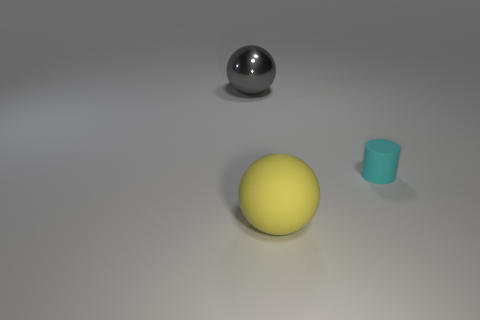Add 1 cyan metallic objects. How many objects exist? 4 Subtract 0 green blocks. How many objects are left? 3 Subtract all balls. How many objects are left? 1 Subtract all green rubber cubes. Subtract all gray spheres. How many objects are left? 2 Add 1 big balls. How many big balls are left? 3 Add 1 cyan things. How many cyan things exist? 2 